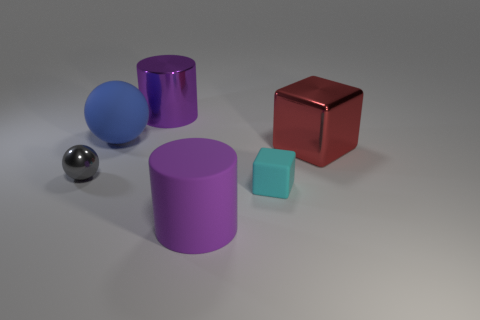What shape is the big metal object that is the same color as the matte cylinder?
Provide a short and direct response. Cylinder. There is a rubber cube; is it the same size as the cylinder in front of the small metal object?
Give a very brief answer. No. What number of rubber balls are the same size as the metal sphere?
Your answer should be compact. 0. How many tiny objects are either balls or cubes?
Your answer should be compact. 2. Are there any gray spheres?
Your answer should be compact. Yes. Are there more large blue objects to the right of the purple rubber cylinder than large matte objects on the left side of the shiny sphere?
Offer a very short reply. No. There is a big metallic thing that is in front of the purple object that is behind the gray thing; what color is it?
Give a very brief answer. Red. Are there any big metal things of the same color as the big shiny cylinder?
Your response must be concise. No. What size is the purple thing that is behind the big rubber thing on the left side of the cylinder to the left of the matte cylinder?
Your answer should be very brief. Large. What is the shape of the small cyan object?
Provide a short and direct response. Cube. 